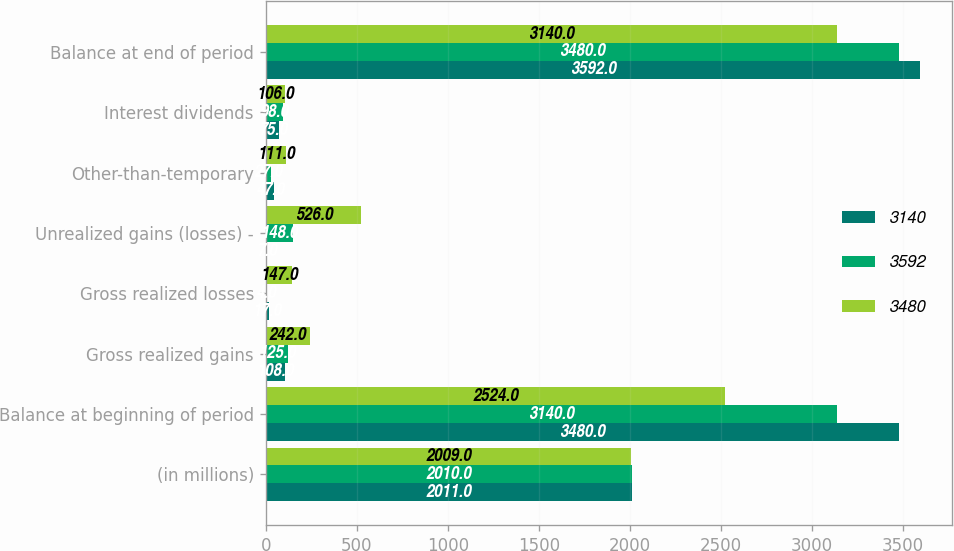Convert chart to OTSL. <chart><loc_0><loc_0><loc_500><loc_500><stacked_bar_chart><ecel><fcel>(in millions)<fcel>Balance at beginning of period<fcel>Gross realized gains<fcel>Gross realized losses<fcel>Unrealized gains (losses) -<fcel>Other-than-temporary<fcel>Interest dividends<fcel>Balance at end of period<nl><fcel>3140<fcel>2011<fcel>3480<fcel>108<fcel>17<fcel>7<fcel>47<fcel>75<fcel>3592<nl><fcel>3592<fcel>2010<fcel>3140<fcel>125<fcel>4<fcel>148<fcel>27<fcel>98<fcel>3480<nl><fcel>3480<fcel>2009<fcel>2524<fcel>242<fcel>147<fcel>526<fcel>111<fcel>106<fcel>3140<nl></chart> 